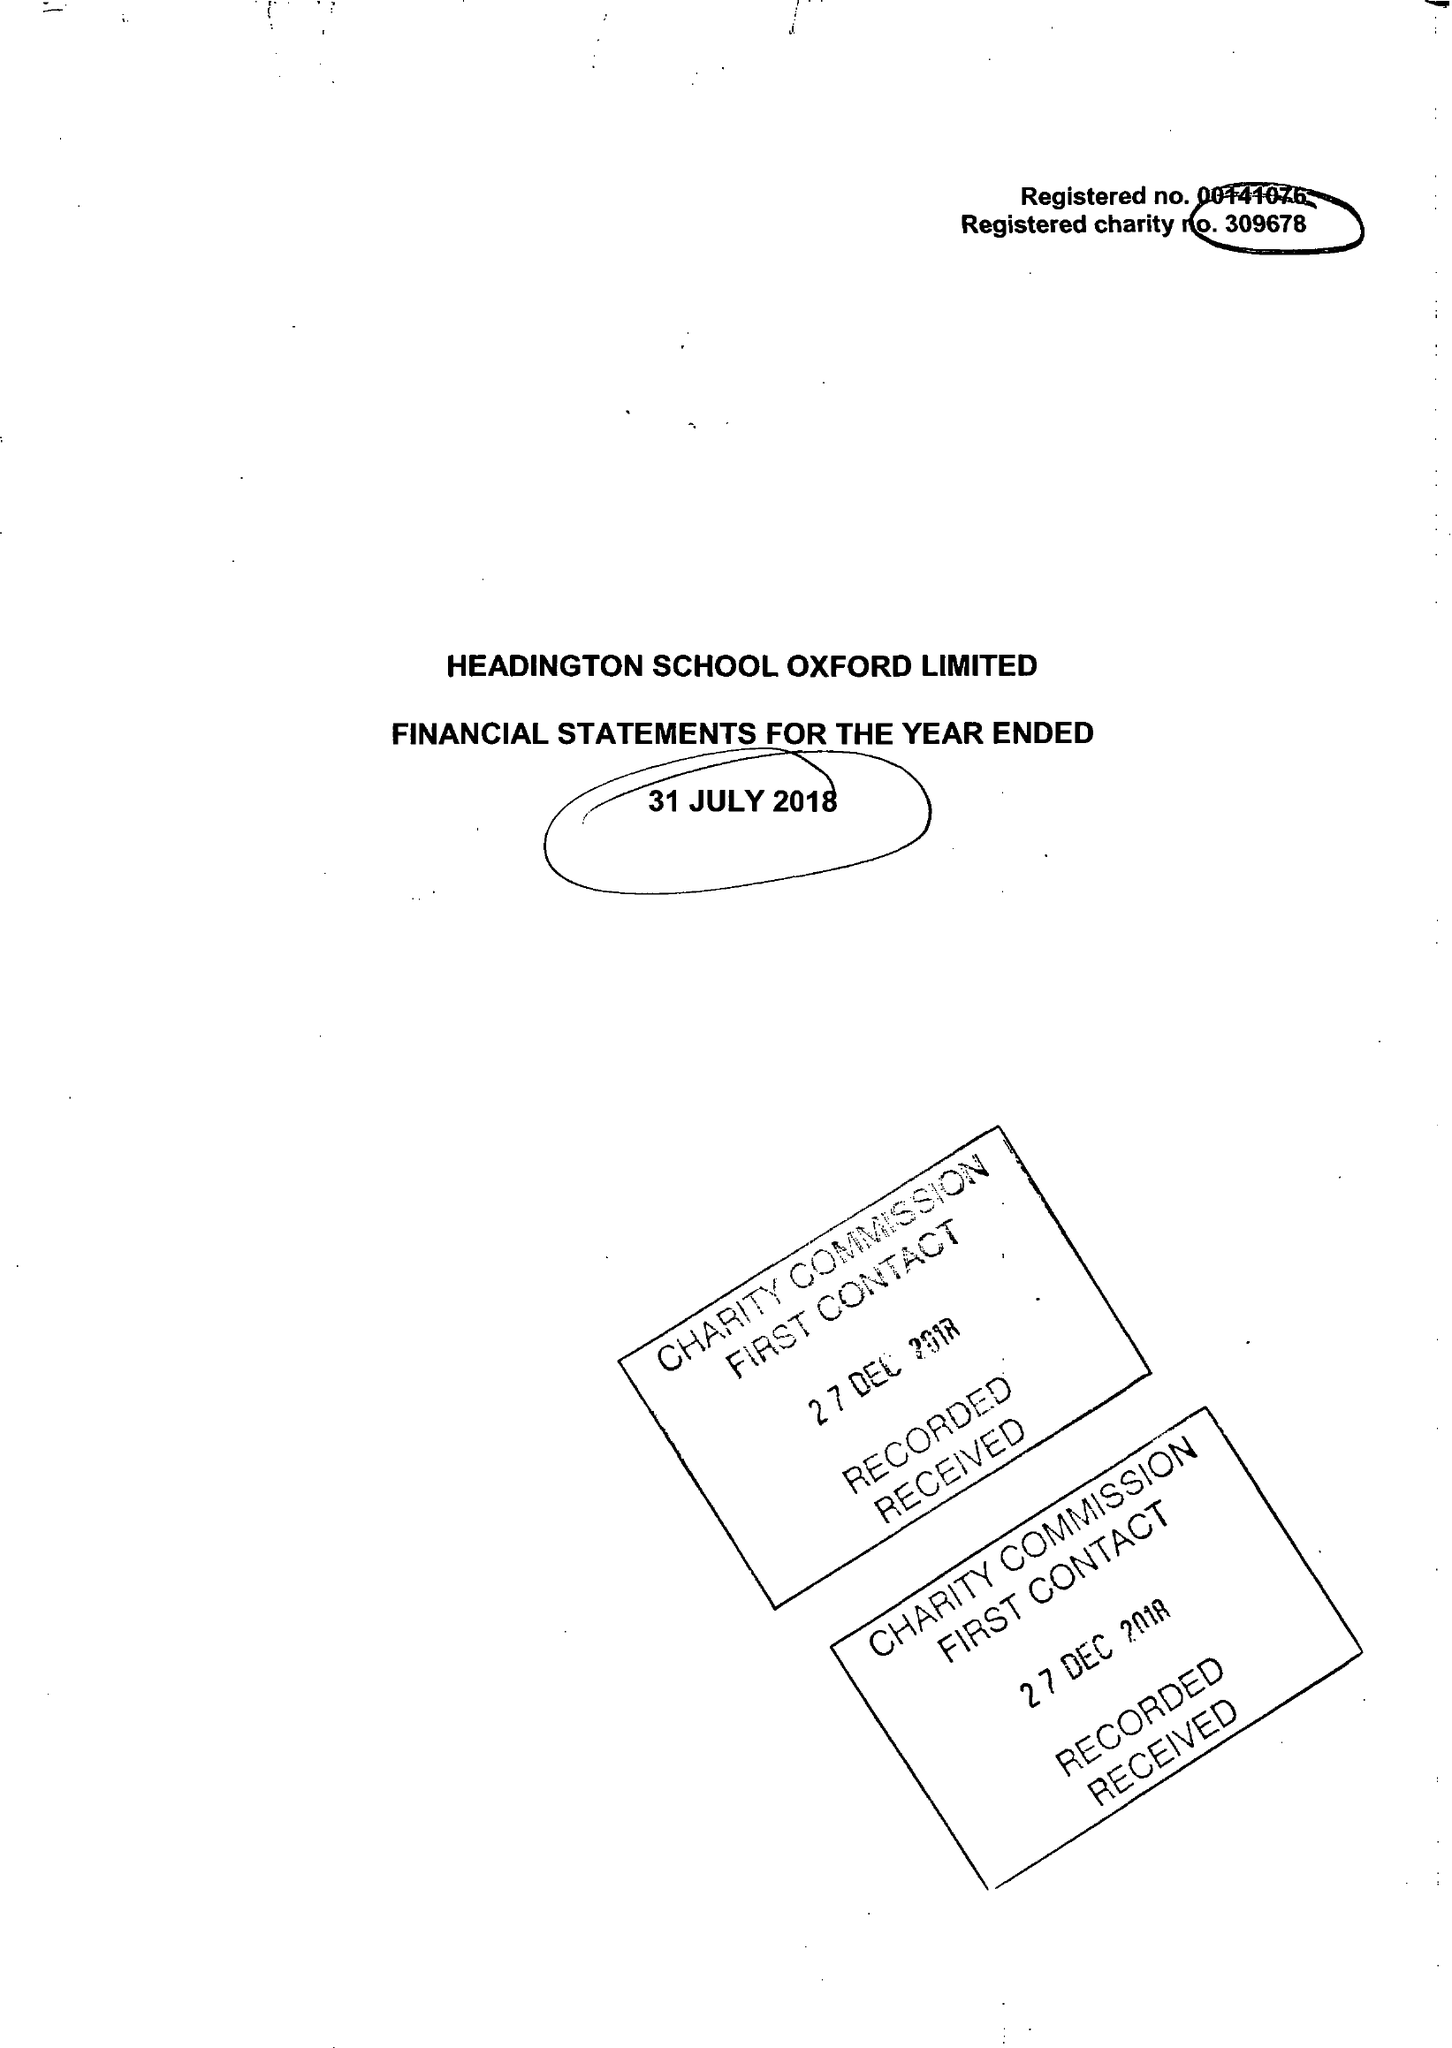What is the value for the charity_number?
Answer the question using a single word or phrase. 309678 